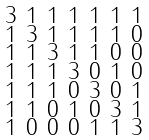Convert formula to latex. <formula><loc_0><loc_0><loc_500><loc_500>\begin{smallmatrix} 3 & 1 & 1 & 1 & 1 & 1 & 1 \\ 1 & 3 & 1 & 1 & 1 & 1 & 0 \\ 1 & 1 & 3 & 1 & 1 & 0 & 0 \\ 1 & 1 & 1 & 3 & 0 & 1 & 0 \\ 1 & 1 & 1 & 0 & 3 & 0 & 1 \\ 1 & 1 & 0 & 1 & 0 & 3 & 1 \\ 1 & 0 & 0 & 0 & 1 & 1 & 3 \end{smallmatrix}</formula> 